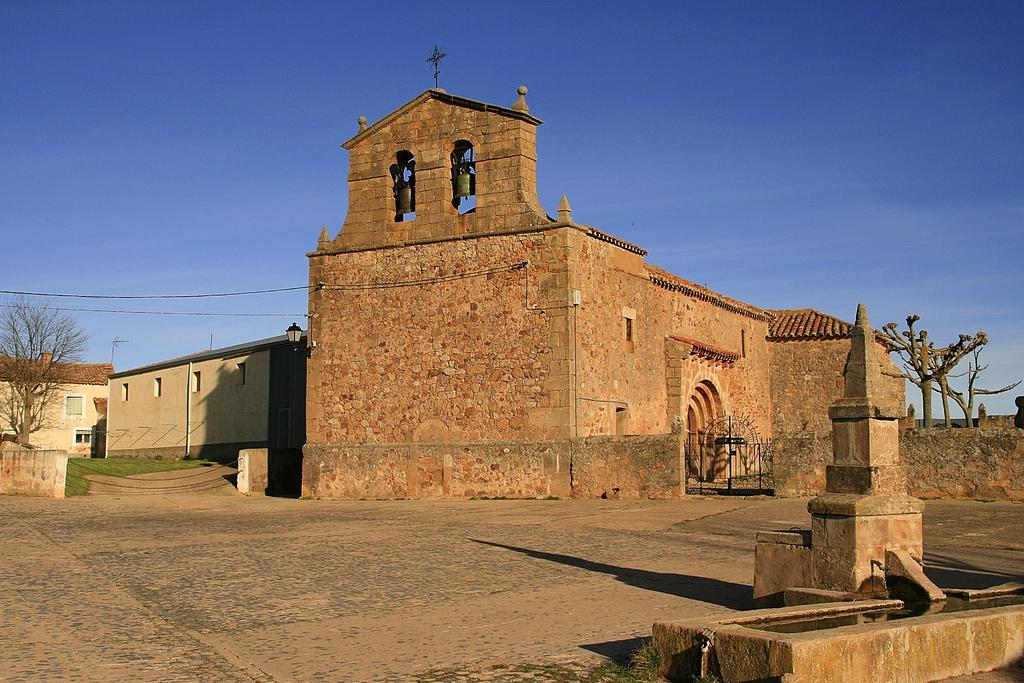What structure can be seen in the image? There is a gate in the image. What else is present in the image besides the gate? There are buildings and trees in the image. What can be seen in the background of the image? The sky is visible in the image. Can you tell me how many pages are in the book that the beggar is holding in the image? There is no book or beggar present in the image. 